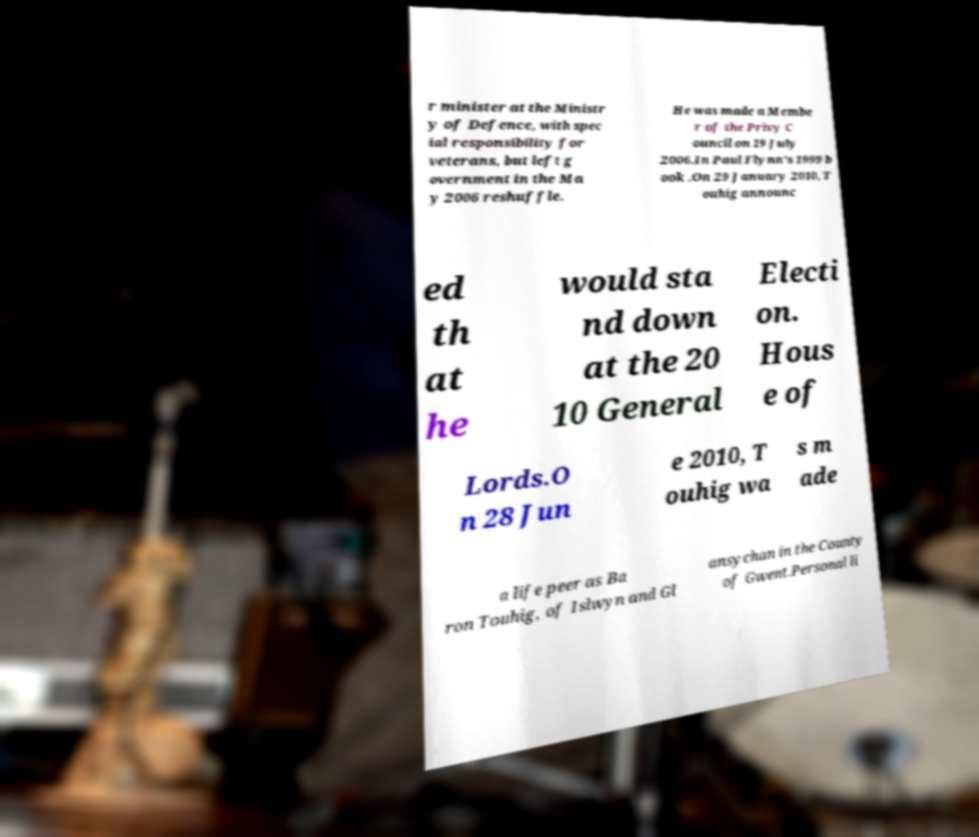Please read and relay the text visible in this image. What does it say? r minister at the Ministr y of Defence, with spec ial responsibility for veterans, but left g overnment in the Ma y 2006 reshuffle. He was made a Membe r of the Privy C ouncil on 19 July 2006.In Paul Flynn's 1999 b ook .On 29 January 2010, T ouhig announc ed th at he would sta nd down at the 20 10 General Electi on. Hous e of Lords.O n 28 Jun e 2010, T ouhig wa s m ade a life peer as Ba ron Touhig, of Islwyn and Gl ansychan in the County of Gwent.Personal li 